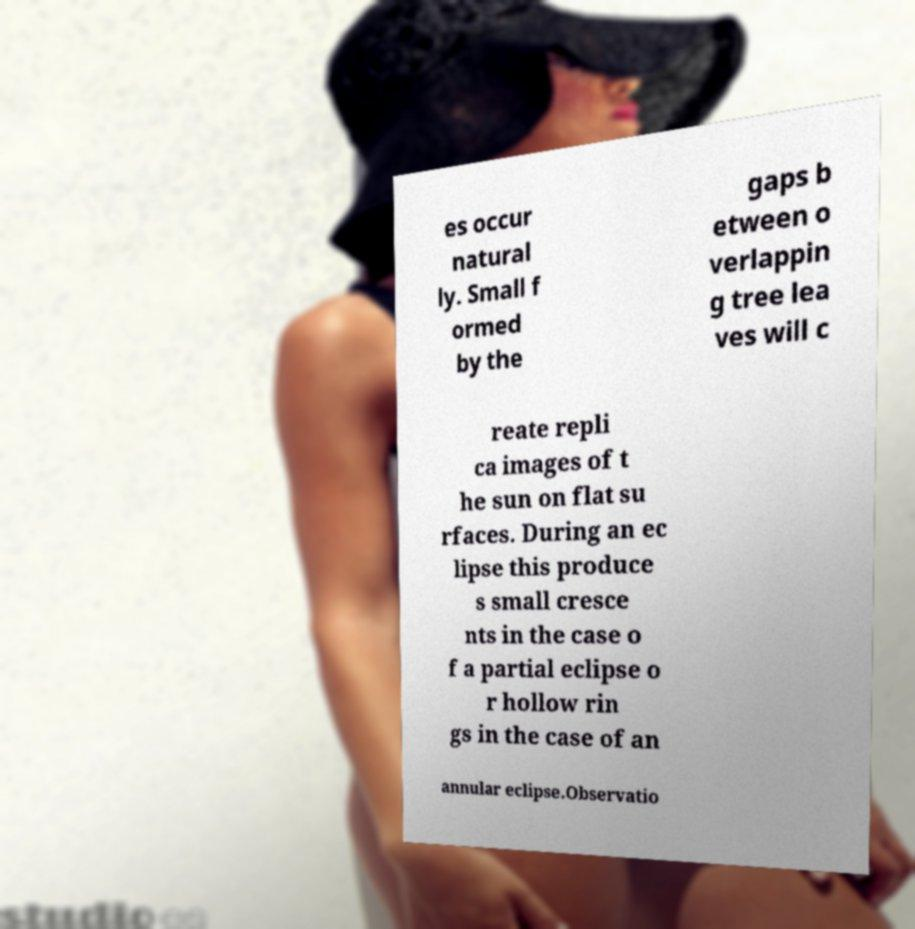There's text embedded in this image that I need extracted. Can you transcribe it verbatim? es occur natural ly. Small f ormed by the gaps b etween o verlappin g tree lea ves will c reate repli ca images of t he sun on flat su rfaces. During an ec lipse this produce s small cresce nts in the case o f a partial eclipse o r hollow rin gs in the case of an annular eclipse.Observatio 